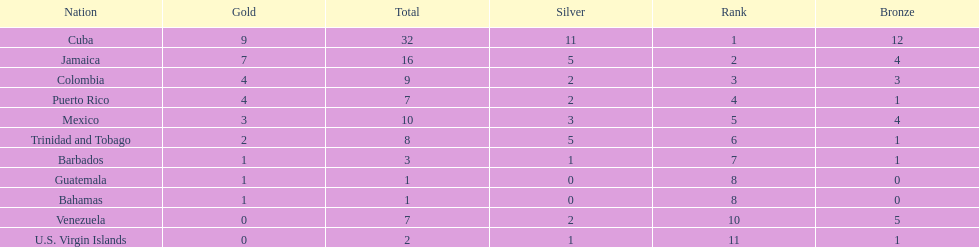Largest medal differential between countries 31. 